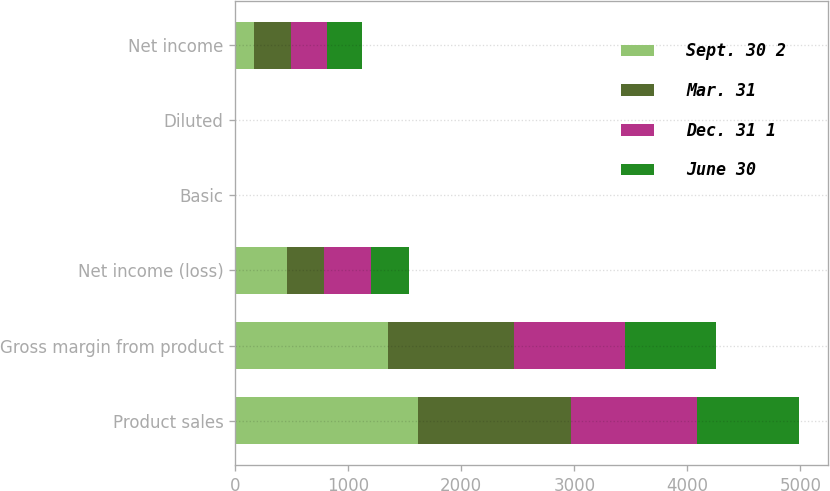Convert chart. <chart><loc_0><loc_0><loc_500><loc_500><stacked_bar_chart><ecel><fcel>Product sales<fcel>Gross margin from product<fcel>Net income (loss)<fcel>Basic<fcel>Diluted<fcel>Net income<nl><fcel>Sept. 30 2<fcel>1621.6<fcel>1347.8<fcel>456.4<fcel>0.35<fcel>0.34<fcel>163<nl><fcel>Mar. 31<fcel>1345.8<fcel>1119.4<fcel>329.9<fcel>2.1<fcel>2.1<fcel>329.9<nl><fcel>Dec. 31 1<fcel>1115.2<fcel>983.3<fcel>412.4<fcel>0.4<fcel>0.38<fcel>321.9<nl><fcel>June 30<fcel>908.6<fcel>805<fcel>340.9<fcel>0.33<fcel>0.32<fcel>304.9<nl></chart> 